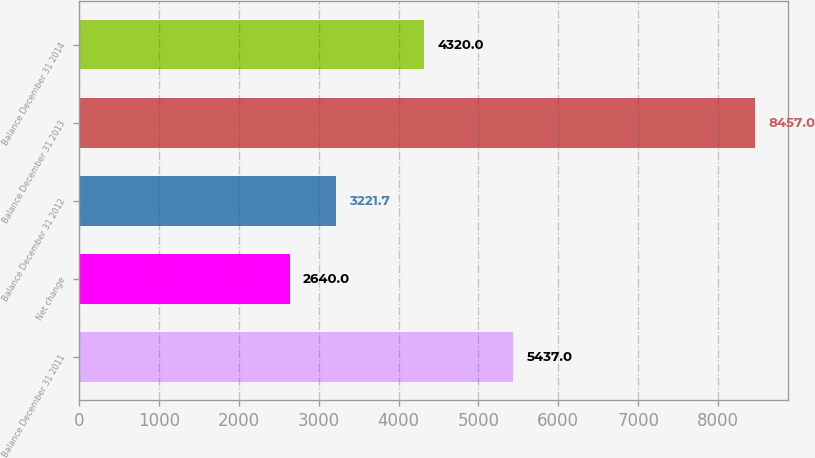<chart> <loc_0><loc_0><loc_500><loc_500><bar_chart><fcel>Balance December 31 2011<fcel>Net change<fcel>Balance December 31 2012<fcel>Balance December 31 2013<fcel>Balance December 31 2014<nl><fcel>5437<fcel>2640<fcel>3221.7<fcel>8457<fcel>4320<nl></chart> 